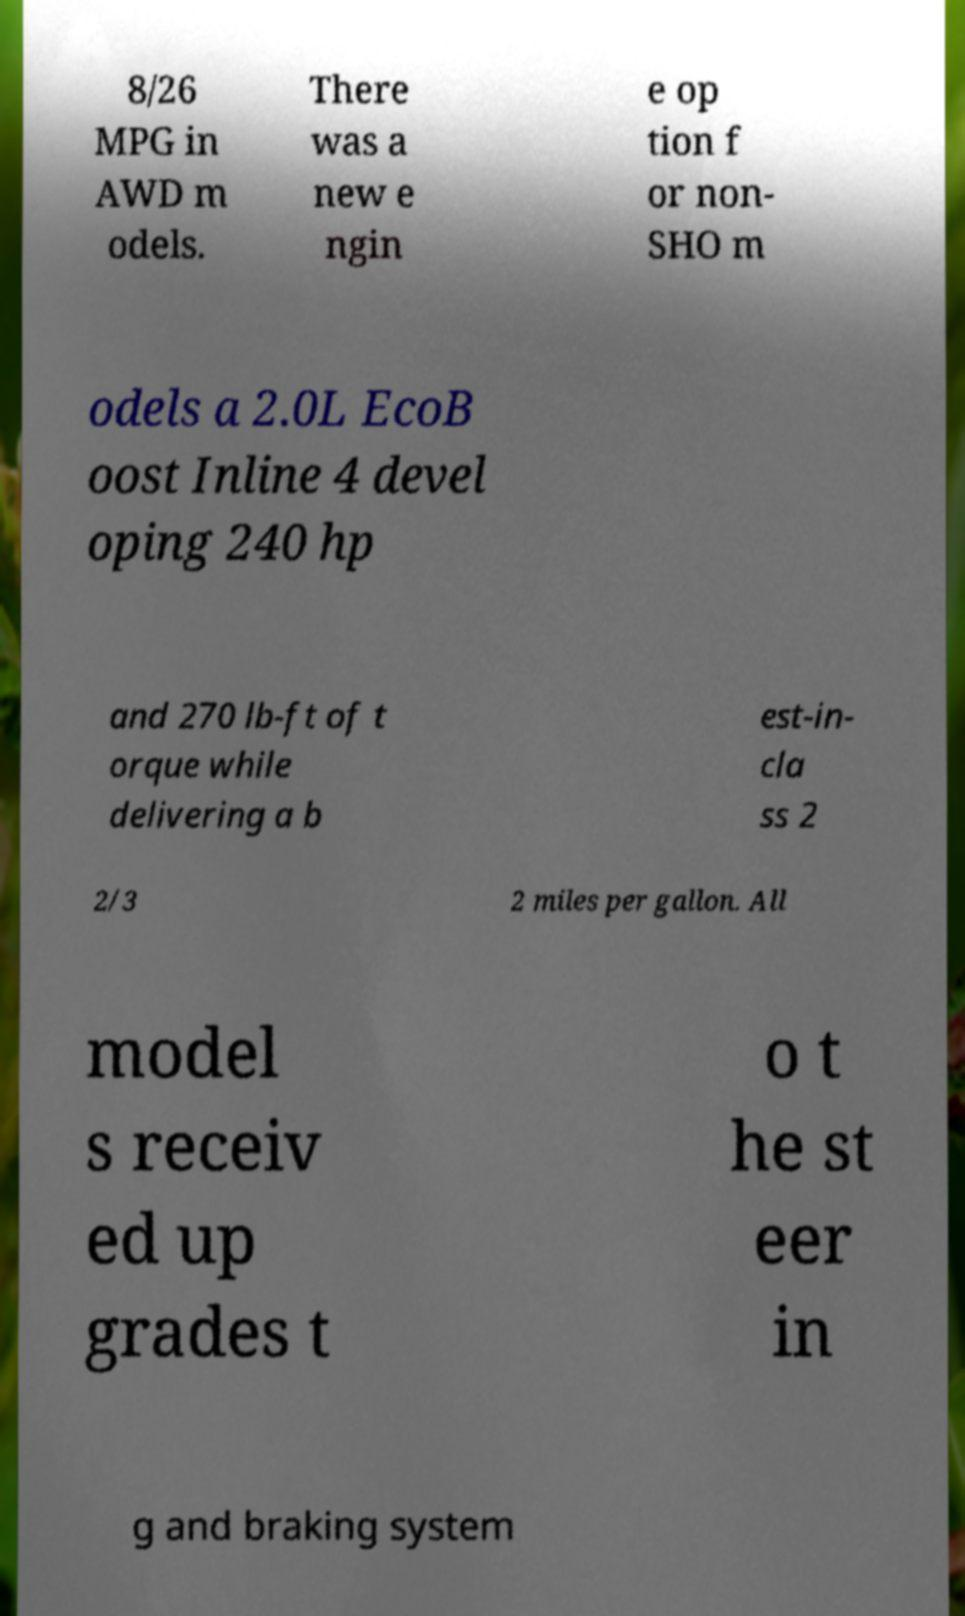What messages or text are displayed in this image? I need them in a readable, typed format. 8/26 MPG in AWD m odels. There was a new e ngin e op tion f or non- SHO m odels a 2.0L EcoB oost Inline 4 devel oping 240 hp and 270 lb-ft of t orque while delivering a b est-in- cla ss 2 2/3 2 miles per gallon. All model s receiv ed up grades t o t he st eer in g and braking system 